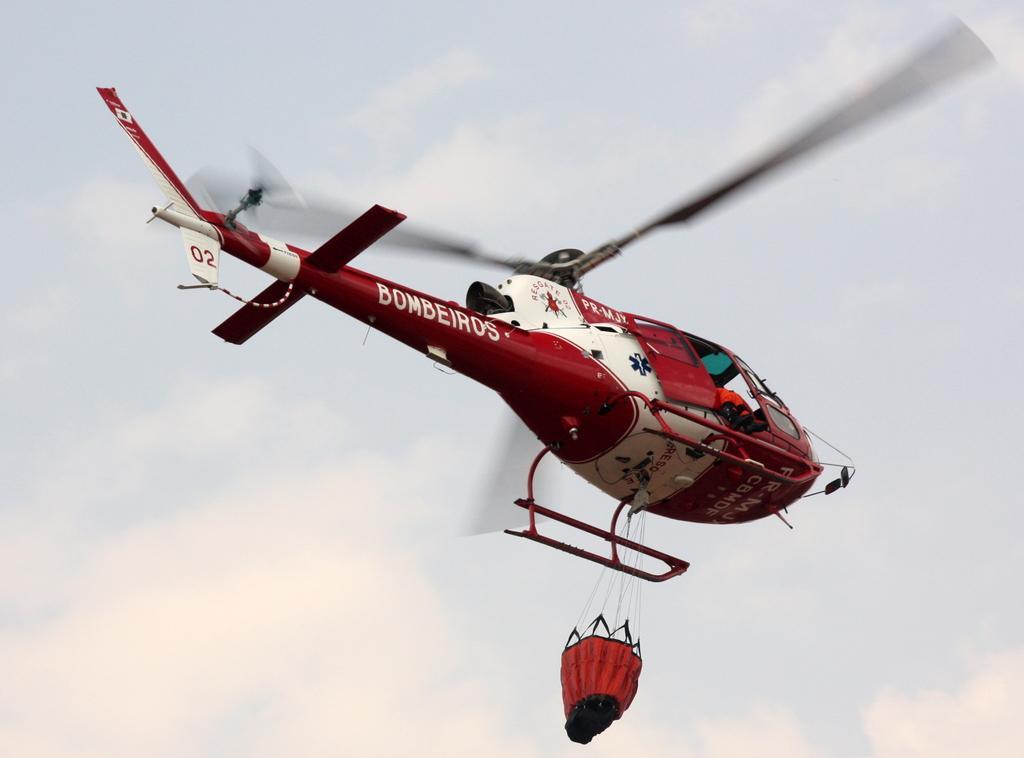Could you give a brief overview of what you see in this image? In the center of the picture there is a helicopter flying. Sky is cloudy. 